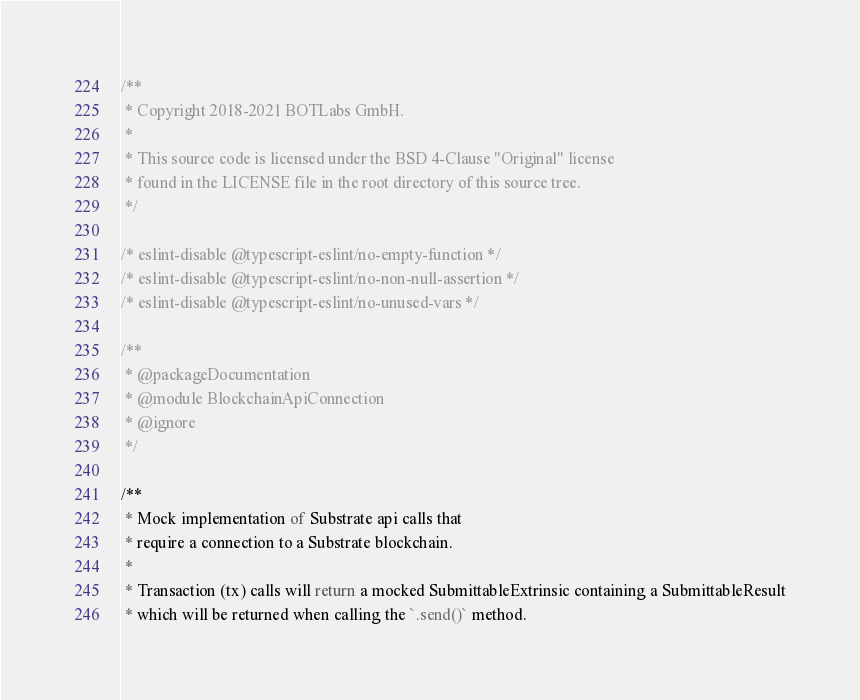<code> <loc_0><loc_0><loc_500><loc_500><_TypeScript_>/**
 * Copyright 2018-2021 BOTLabs GmbH.
 *
 * This source code is licensed under the BSD 4-Clause "Original" license
 * found in the LICENSE file in the root directory of this source tree.
 */

/* eslint-disable @typescript-eslint/no-empty-function */
/* eslint-disable @typescript-eslint/no-non-null-assertion */
/* eslint-disable @typescript-eslint/no-unused-vars */

/**
 * @packageDocumentation
 * @module BlockchainApiConnection
 * @ignore
 */

/**
 * Mock implementation of Substrate api calls that
 * require a connection to a Substrate blockchain.
 *
 * Transaction (tx) calls will return a mocked SubmittableExtrinsic containing a SubmittableResult
 * which will be returned when calling the `.send()` method.</code> 